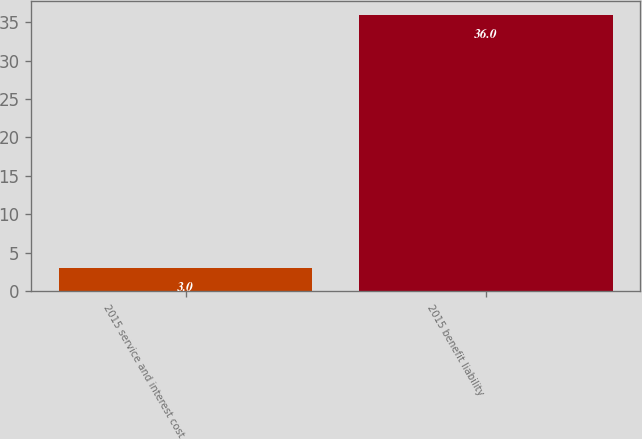Convert chart. <chart><loc_0><loc_0><loc_500><loc_500><bar_chart><fcel>2015 service and interest cost<fcel>2015 benefit liability<nl><fcel>3<fcel>36<nl></chart> 